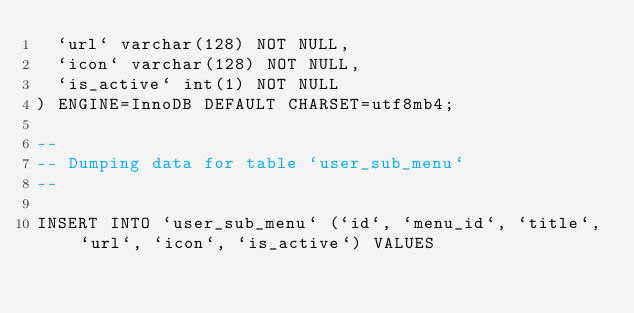<code> <loc_0><loc_0><loc_500><loc_500><_SQL_>  `url` varchar(128) NOT NULL,
  `icon` varchar(128) NOT NULL,
  `is_active` int(1) NOT NULL
) ENGINE=InnoDB DEFAULT CHARSET=utf8mb4;

--
-- Dumping data for table `user_sub_menu`
--

INSERT INTO `user_sub_menu` (`id`, `menu_id`, `title`, `url`, `icon`, `is_active`) VALUES</code> 